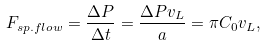Convert formula to latex. <formula><loc_0><loc_0><loc_500><loc_500>F _ { s p . f l o w } = \frac { \Delta P } { \Delta t } = \frac { \Delta P v _ { L } } { a } = \pi C _ { 0 } v _ { L } ,</formula> 